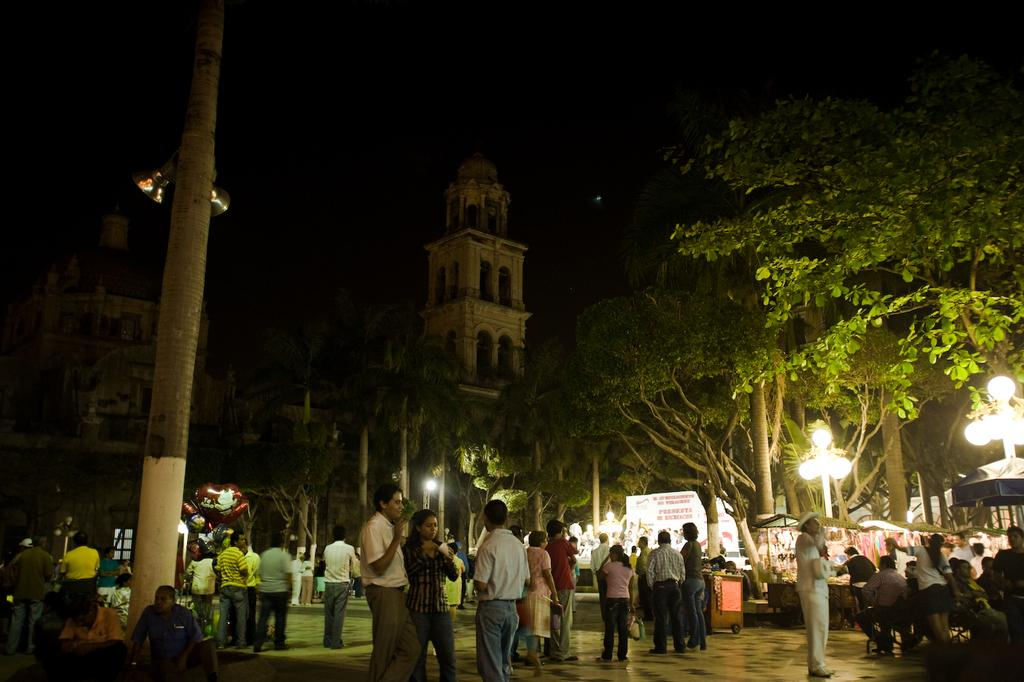How many people are in the image? There is a group of people standing in the image. What can be seen in the image besides the people? There are lights, poles, balloons, trees, stalls, and buildings in the background of the image. What might the poles be used for? The poles could be used to support lights, balloons, or other decorations. What type of structures are visible in the background? There are buildings in the background of the image. Can you see a hydrant in the image? There is no hydrant present in the image. What type of engine is powering the balloons in the image? There are no engines present in the image; the balloons are likely filled with helium or another lighter-than-air gas. 